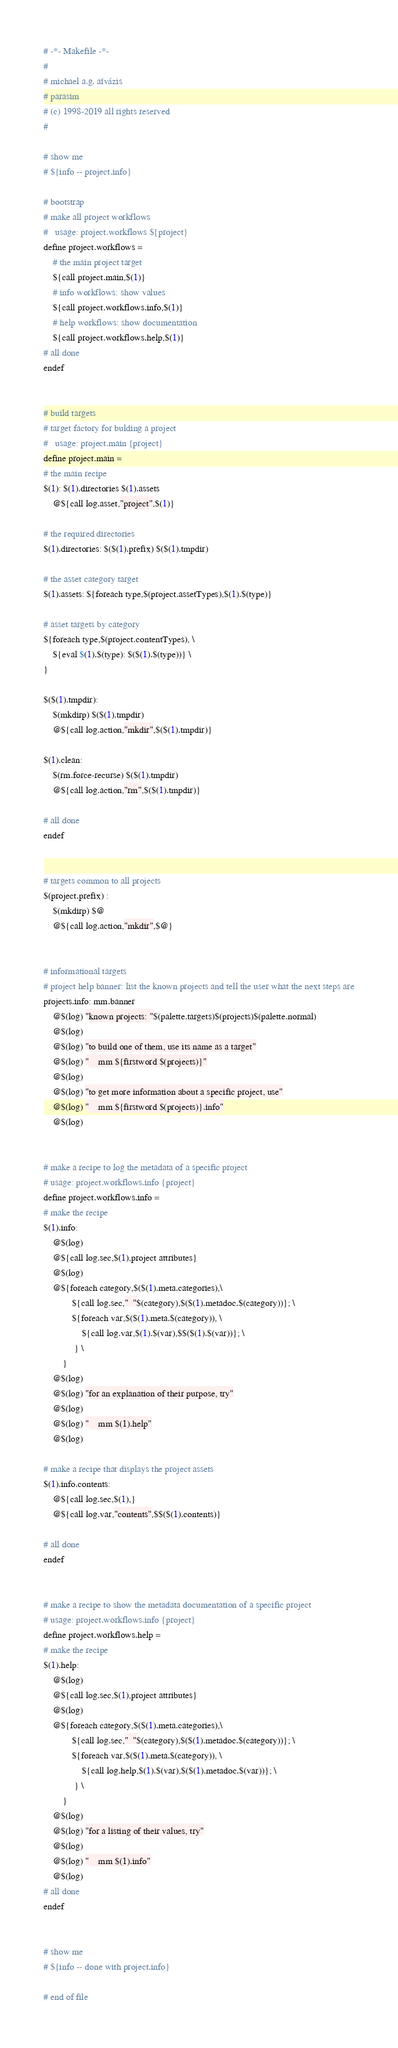<code> <loc_0><loc_0><loc_500><loc_500><_ObjectiveC_># -*- Makefile -*-
#
# michael a.g. aïvázis
# parasim
# (c) 1998-2019 all rights reserved
#

# show me
# ${info -- project.info}

# bootstrap
# make all project workflows
#   usage: project.workflows ${project}
define project.workflows =
    # the main project target
    ${call project.main,$(1)}
    # info workflows: show values
    ${call project.workflows.info,$(1)}
    # help workflows: show documentation
    ${call project.workflows.help,$(1)}
# all done
endef


# build targets
# target factory for bulding a project
#   usage: project.main {project}
define project.main =
# the main recipe
$(1): $(1).directories $(1).assets
	@${call log.asset,"project",$(1)}

# the required directories
$(1).directories: $($(1).prefix) $($(1).tmpdir)

# the asset category target
$(1).assets: ${foreach type,$(project.assetTypes),$(1).$(type)}

# asset targets by category
${foreach type,$(project.contentTypes), \
    ${eval $(1).$(type): $($(1).$(type))} \
}

$($(1).tmpdir):
	$(mkdirp) $($(1).tmpdir)
	@${call log.action,"mkdir",$($(1).tmpdir)}

$(1).clean:
	$(rm.force-recurse) $($(1).tmpdir)
	@${call log.action,"rm",$($(1).tmpdir)}

# all done
endef


# targets common to all projects
$(project.prefix) :
	$(mkdirp) $@
	@${call log.action,"mkdir",$@}


# informational targets
# project help banner: list the known projects and tell the user what the next steps are
projects.info: mm.banner
	@$(log) "known projects: "$(palette.targets)$(projects)$(palette.normal)
	@$(log)
	@$(log) "to build one of them, use its name as a target"
	@$(log) "    mm ${firstword $(projects)}"
	@$(log)
	@$(log) "to get more information about a specific project, use"
	@$(log) "    mm ${firstword $(projects)}.info"
	@$(log)


# make a recipe to log the metadata of a specific project
# usage: project.workflows.info {project}
define project.workflows.info =
# make the recipe
$(1).info:
	@$(log)
	@${call log.sec,$(1),project attributes}
	@$(log)
	@${foreach category,$($(1).meta.categories),\
            ${call log.sec,"  "$(category),$($(1).metadoc.$(category))}; \
            ${foreach var,$($(1).meta.$(category)), \
                ${call log.var,$(1).$(var),$$($(1).$(var))}; \
             } \
        }
	@$(log)
	@$(log) "for an explanation of their purpose, try"
	@$(log)
	@$(log) "    mm $(1).help"
	@$(log)

# make a recipe that displays the project assets
$(1).info.contents:
	@${call log.sec,$(1),}
	@${call log.var,"contents",$$($(1).contents)}

# all done
endef


# make a recipe to show the metadata documentation of a specific project
# usage: project.workflows.info {project}
define project.workflows.help =
# make the recipe
$(1).help:
	@$(log)
	@${call log.sec,$(1),project attributes}
	@$(log)
	@${foreach category,$($(1).meta.categories),\
            ${call log.sec,"  "$(category),$($(1).metadoc.$(category))}; \
            ${foreach var,$($(1).meta.$(category)), \
                ${call log.help,$(1).$(var),$($(1).metadoc.$(var))}; \
             } \
        }
	@$(log)
	@$(log) "for a listing of their values, try"
	@$(log)
	@$(log) "    mm $(1).info"
	@$(log)
# all done
endef


# show me
# ${info -- done with project.info}

# end of file
</code> 